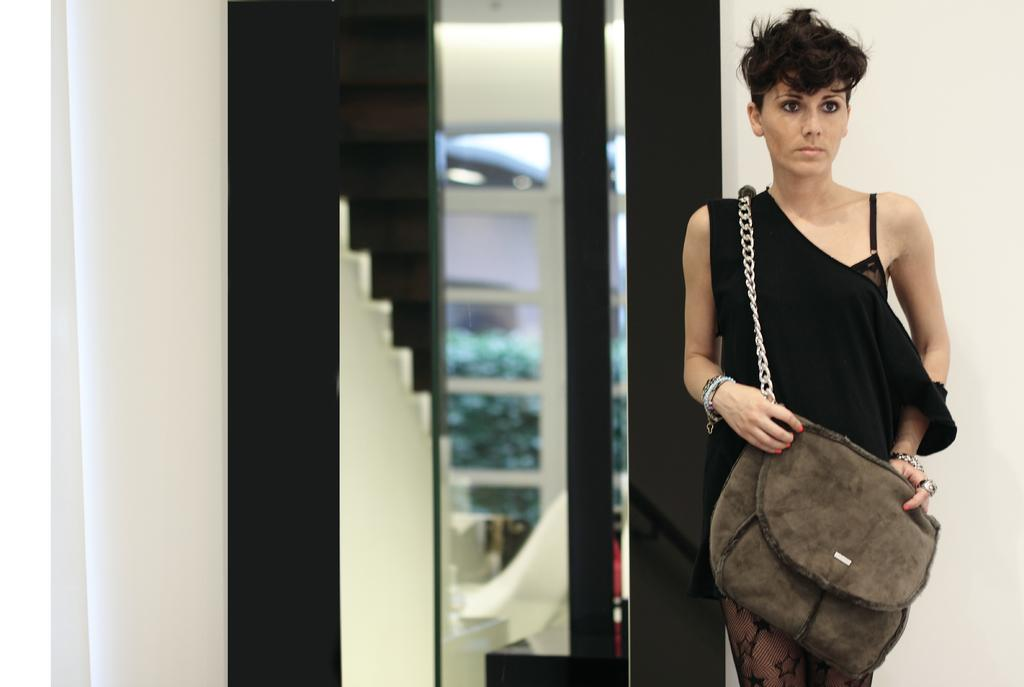Who is present in the image? There is a woman in the image. What is the woman wearing? The woman is wearing a black dress. What is the woman doing in the image? The woman is standing. What can be seen in the background of the image? There is a wall, clothes, a window, and trees visible in the background. How many yams are being served by the servant in the image? There is no servant or yams present in the image. What type of snakes can be seen slithering through the trees in the image? There are no snakes visible in the image; only trees can be seen through the window. 